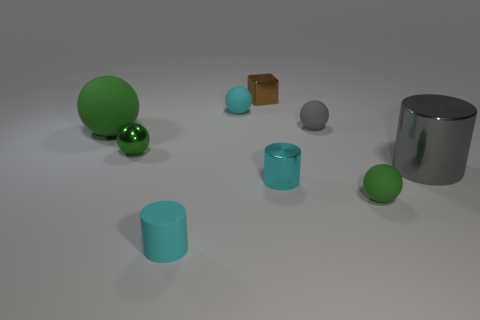Subtract all green balls. How many were subtracted if there are1green balls left? 2 Add 2 cyan cylinders. How many cyan cylinders exist? 4 Subtract all cyan cylinders. How many cylinders are left? 1 Subtract all cyan balls. How many balls are left? 4 Subtract 0 green cubes. How many objects are left? 9 Subtract all cubes. How many objects are left? 8 Subtract 2 spheres. How many spheres are left? 3 Subtract all purple balls. Subtract all brown cubes. How many balls are left? 5 Subtract all cyan cylinders. How many cyan spheres are left? 1 Subtract all big yellow matte things. Subtract all small gray balls. How many objects are left? 8 